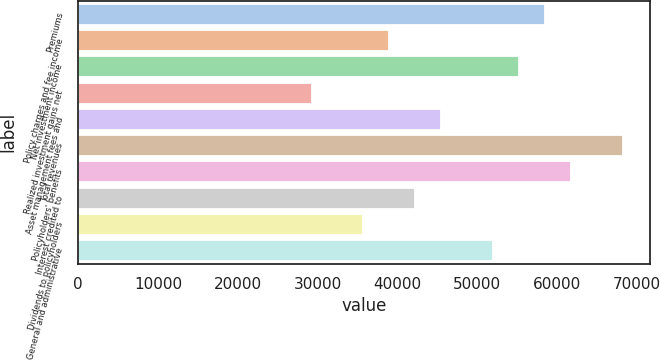Convert chart to OTSL. <chart><loc_0><loc_0><loc_500><loc_500><bar_chart><fcel>Premiums<fcel>Policy charges and fee income<fcel>Net investment income<fcel>Realized investment gains net<fcel>Asset management fees and<fcel>Total revenues<fcel>Policyholders' benefits<fcel>Interest credited to<fcel>Dividends to policyholders<fcel>General and administrative<nl><fcel>58478.3<fcel>38985.6<fcel>55229.6<fcel>29239.2<fcel>45483.2<fcel>68224.7<fcel>61727.1<fcel>42234.4<fcel>35736.8<fcel>51980.8<nl></chart> 